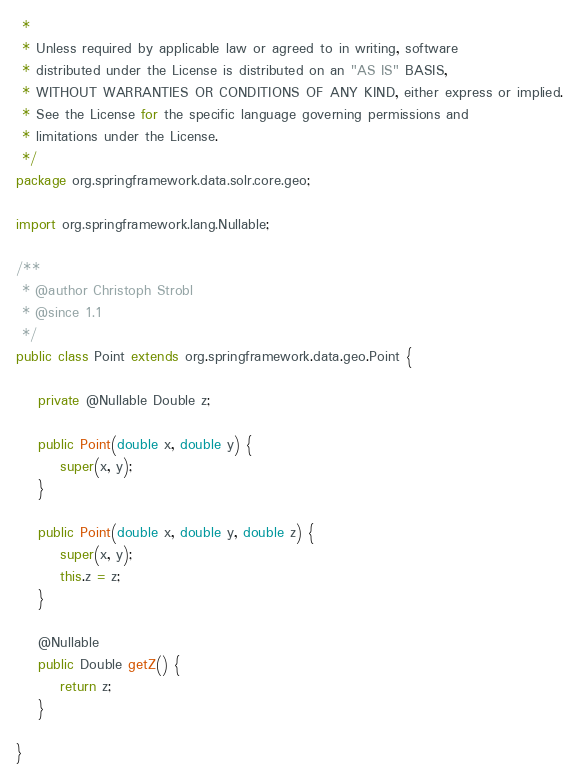<code> <loc_0><loc_0><loc_500><loc_500><_Java_> *
 * Unless required by applicable law or agreed to in writing, software
 * distributed under the License is distributed on an "AS IS" BASIS,
 * WITHOUT WARRANTIES OR CONDITIONS OF ANY KIND, either express or implied.
 * See the License for the specific language governing permissions and
 * limitations under the License.
 */
package org.springframework.data.solr.core.geo;

import org.springframework.lang.Nullable;

/**
 * @author Christoph Strobl
 * @since 1.1
 */
public class Point extends org.springframework.data.geo.Point {

	private @Nullable Double z;

	public Point(double x, double y) {
		super(x, y);
	}

	public Point(double x, double y, double z) {
		super(x, y);
		this.z = z;
	}

	@Nullable
	public Double getZ() {
		return z;
	}

}
</code> 